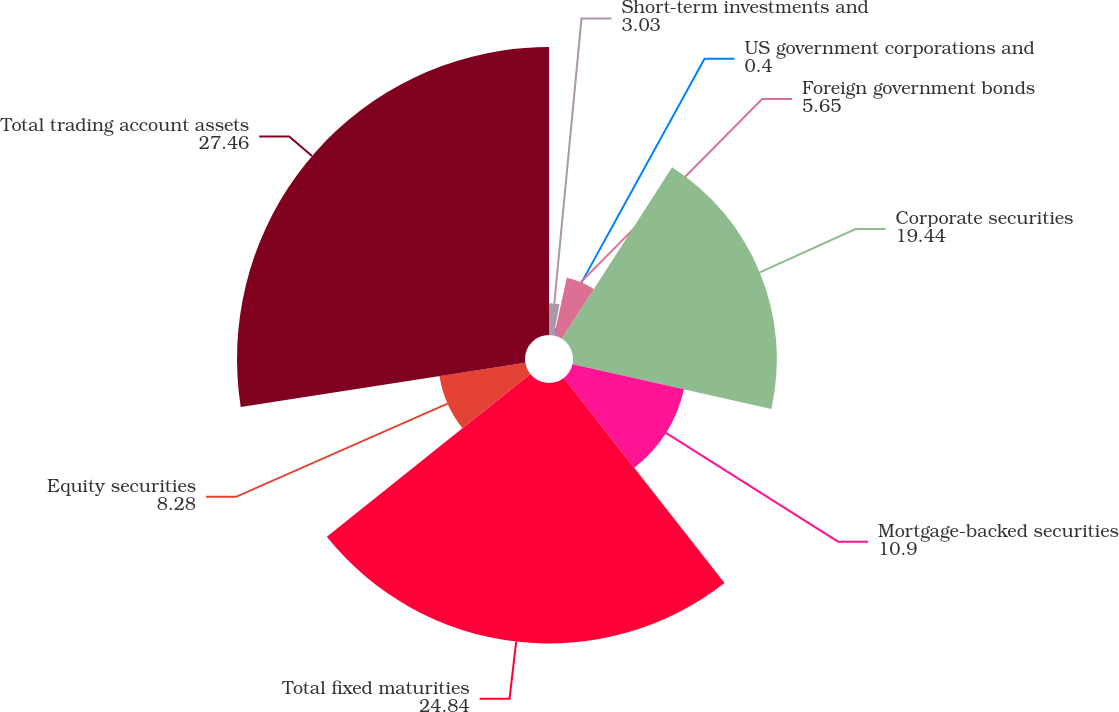Convert chart. <chart><loc_0><loc_0><loc_500><loc_500><pie_chart><fcel>Short-term investments and<fcel>US government corporations and<fcel>Foreign government bonds<fcel>Corporate securities<fcel>Mortgage-backed securities<fcel>Total fixed maturities<fcel>Equity securities<fcel>Total trading account assets<nl><fcel>3.03%<fcel>0.4%<fcel>5.65%<fcel>19.44%<fcel>10.9%<fcel>24.84%<fcel>8.28%<fcel>27.46%<nl></chart> 